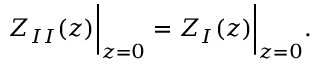Convert formula to latex. <formula><loc_0><loc_0><loc_500><loc_500>Z _ { I I } ( z ) \left | _ { z = 0 } = Z _ { I } ( z ) \right | _ { z = 0 } .</formula> 